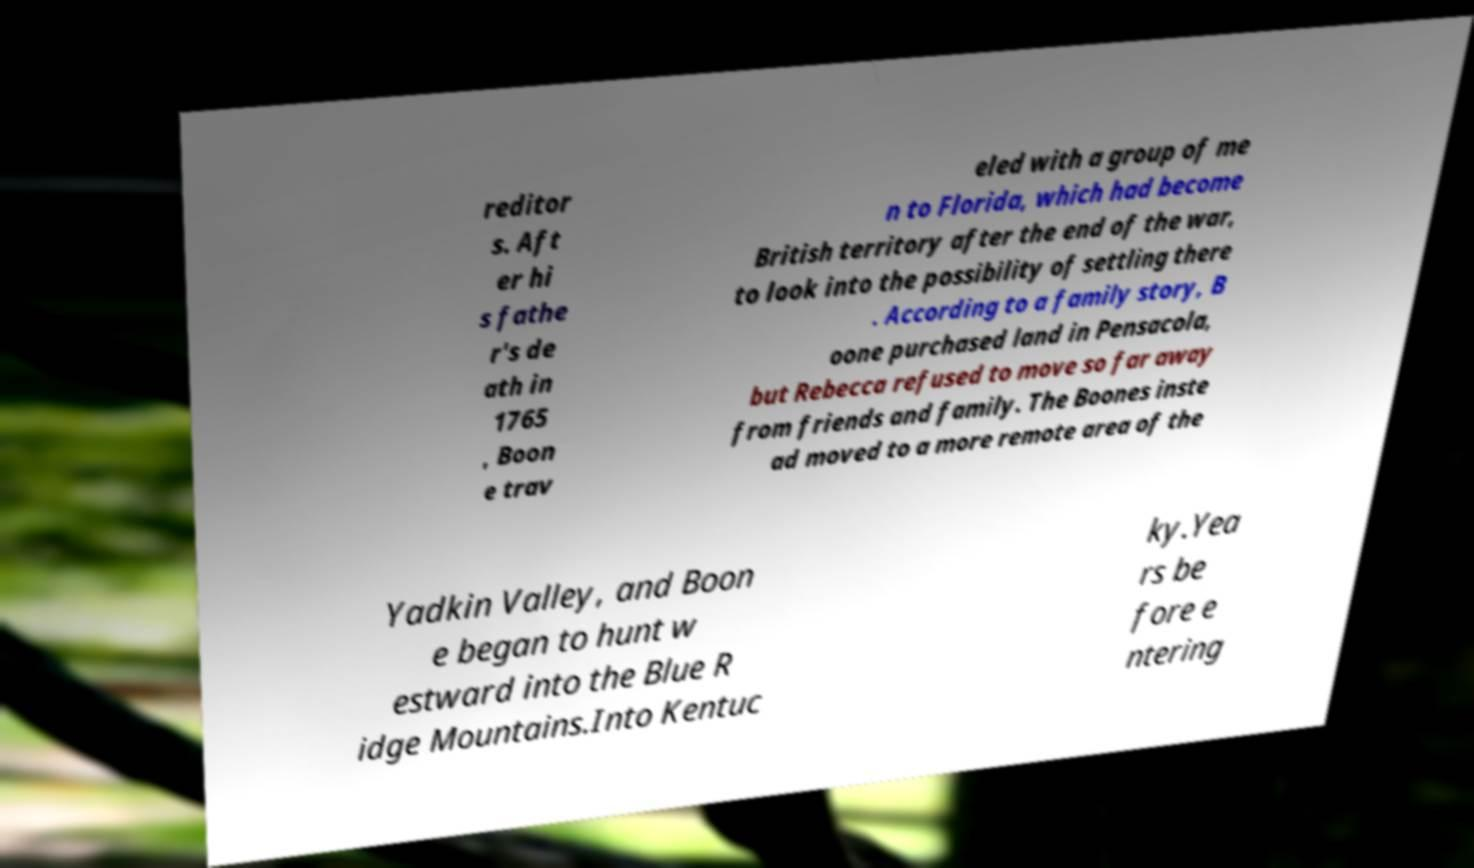Can you accurately transcribe the text from the provided image for me? reditor s. Aft er hi s fathe r's de ath in 1765 , Boon e trav eled with a group of me n to Florida, which had become British territory after the end of the war, to look into the possibility of settling there . According to a family story, B oone purchased land in Pensacola, but Rebecca refused to move so far away from friends and family. The Boones inste ad moved to a more remote area of the Yadkin Valley, and Boon e began to hunt w estward into the Blue R idge Mountains.Into Kentuc ky.Yea rs be fore e ntering 